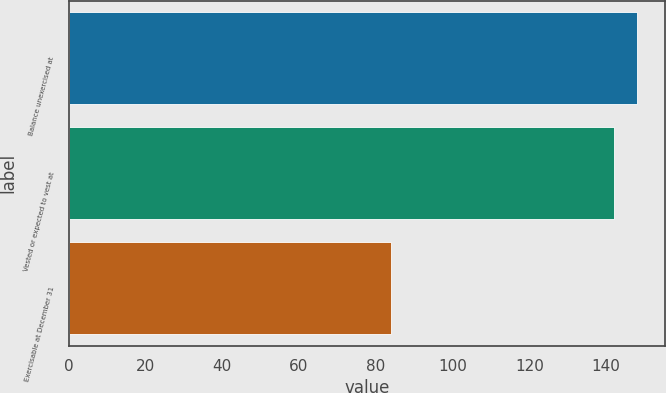Convert chart. <chart><loc_0><loc_0><loc_500><loc_500><bar_chart><fcel>Balance unexercised at<fcel>Vested or expected to vest at<fcel>Exercisable at December 31<nl><fcel>148.05<fcel>142.09<fcel>84.01<nl></chart> 